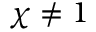<formula> <loc_0><loc_0><loc_500><loc_500>\chi \neq 1</formula> 